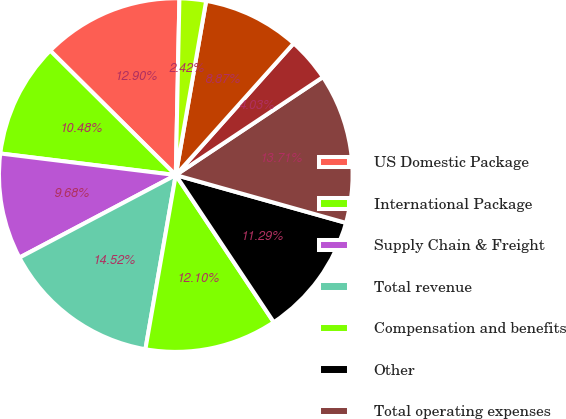Convert chart to OTSL. <chart><loc_0><loc_0><loc_500><loc_500><pie_chart><fcel>US Domestic Package<fcel>International Package<fcel>Supply Chain & Freight<fcel>Total revenue<fcel>Compensation and benefits<fcel>Other<fcel>Total operating expenses<fcel>Supply Chain and Freight<fcel>Total operating profit<fcel>Investment income<nl><fcel>12.9%<fcel>10.48%<fcel>9.68%<fcel>14.52%<fcel>12.1%<fcel>11.29%<fcel>13.71%<fcel>4.03%<fcel>8.87%<fcel>2.42%<nl></chart> 